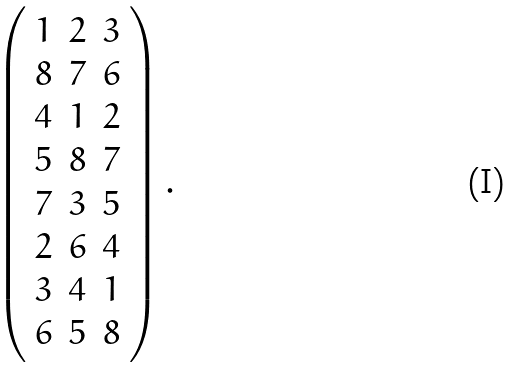<formula> <loc_0><loc_0><loc_500><loc_500>\left ( \begin{array} { c c c } 1 & 2 & 3 \\ 8 & 7 & 6 \\ 4 & 1 & 2 \\ 5 & 8 & 7 \\ 7 & 3 & 5 \\ 2 & 6 & 4 \\ 3 & 4 & 1 \\ 6 & 5 & 8 \end{array} \right ) .</formula> 